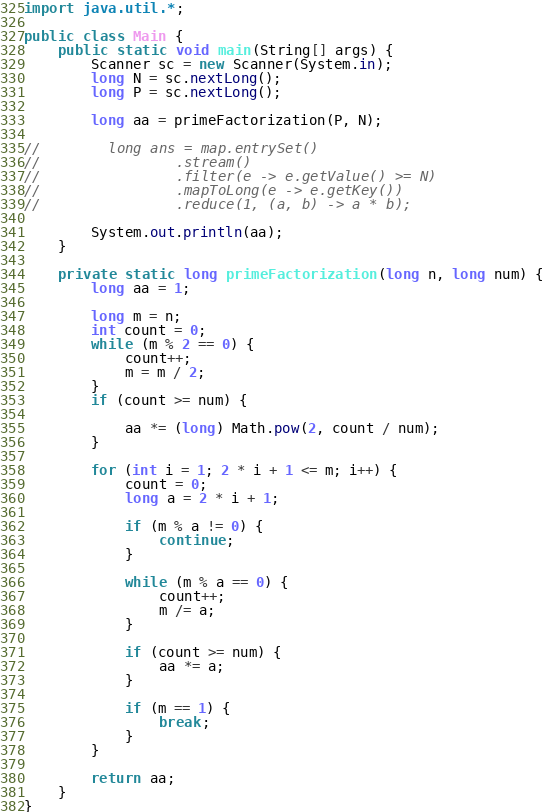<code> <loc_0><loc_0><loc_500><loc_500><_Java_>import java.util.*;

public class Main {
    public static void main(String[] args) {
        Scanner sc = new Scanner(System.in);
        long N = sc.nextLong();
        long P = sc.nextLong();

        long aa = primeFactorization(P, N);

//        long ans = map.entrySet()
//                .stream()
//                .filter(e -> e.getValue() >= N)
//                .mapToLong(e -> e.getKey())
//                .reduce(1, (a, b) -> a * b);

        System.out.println(aa);
    }

    private static long primeFactorization(long n, long num) {
        long aa = 1;

        long m = n;
        int count = 0;
        while (m % 2 == 0) {
            count++;
            m = m / 2;
        }
        if (count >= num) {

            aa *= (long) Math.pow(2, count / num);
        }

        for (int i = 1; 2 * i + 1 <= m; i++) {
            count = 0;
            long a = 2 * i + 1;

            if (m % a != 0) {
                continue;
            }

            while (m % a == 0) {
                count++;
                m /= a;
            }

            if (count >= num) {
                aa *= a;
            }

            if (m == 1) {
                break;
            }
        }

        return aa;
    }
}</code> 